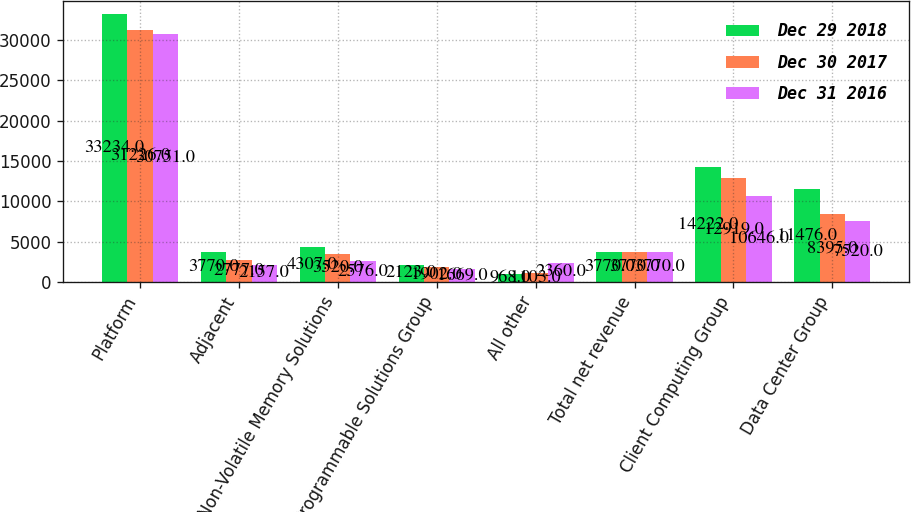<chart> <loc_0><loc_0><loc_500><loc_500><stacked_bar_chart><ecel><fcel>Platform<fcel>Adjacent<fcel>Non-Volatile Memory Solutions<fcel>Programmable Solutions Group<fcel>All other<fcel>Total net revenue<fcel>Client Computing Group<fcel>Data Center Group<nl><fcel>Dec 29 2018<fcel>33234<fcel>3770<fcel>4307<fcel>2123<fcel>968<fcel>3770<fcel>14222<fcel>11476<nl><fcel>Dec 30 2017<fcel>31226<fcel>2777<fcel>3520<fcel>1902<fcel>1103<fcel>3770<fcel>12919<fcel>8395<nl><fcel>Dec 31 2016<fcel>30751<fcel>2157<fcel>2576<fcel>1669<fcel>2360<fcel>3770<fcel>10646<fcel>7520<nl></chart> 